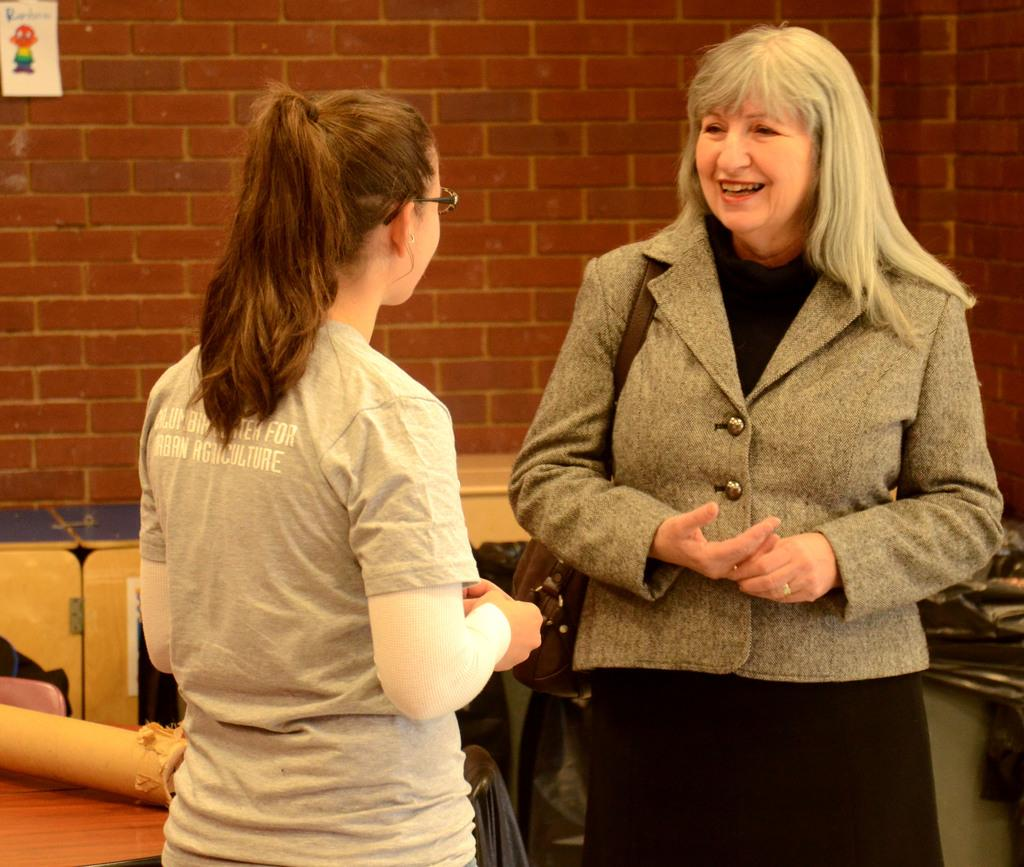How many women are in the image? There are two women in the foreground of the image. What can be seen in the background of the image? There is a wall in the background of the image. Are there any objects in front of the wall? There may be tables in front of the wall. What else can be seen in the background of the image? There are other objects visible in the background. What type of cabbage is growing on the wall in the image? There is no cabbage visible in the image; the background features a wall and other objects, but no plants or vegetables. 